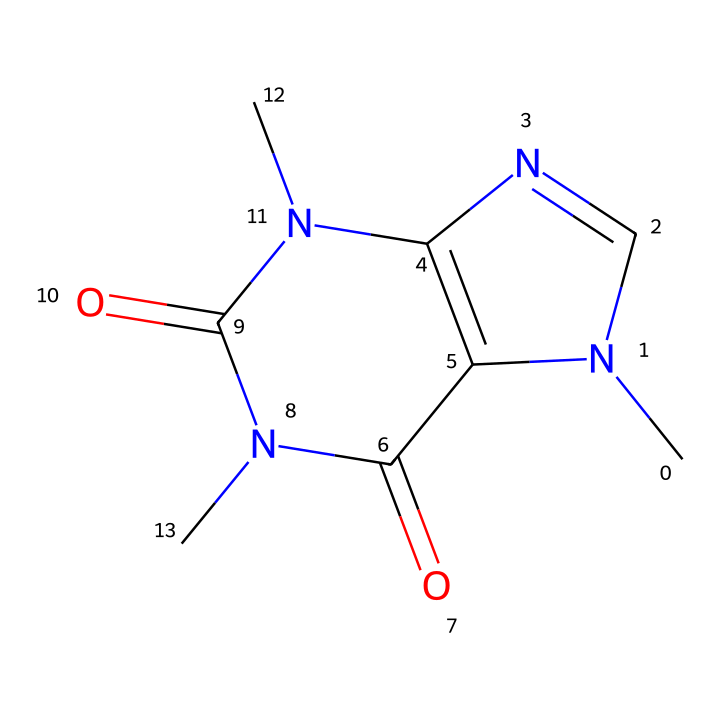What is the molecular formula for this compound? By analyzing the structure, we can count each type of atom present. The chemical contains 8 carbon (C) atoms, 10 hydrogen (H) atoms, and 4 nitrogen (N) atoms, leading to the molecular formula C8H10N4O2.
Answer: C8H10N4O2 How many rings are in this chemical structure? The structure shows that there are two interconnected ring systems. By tracing the bonds, it's clear that there are two circular arrangements present.
Answer: 2 What functional groups can be identified in this compound? Observing the structure reveals two carbonyl groups (C=O) and amine groups (N), which are indicative of its alkaloid nature. The presence of these groups highlights the overall functionality of the molecule.
Answer: amine and carbonyl Does this compound possess basic or acidic properties? Given that the chemical contains nitrogen atoms, which can accept protons, this compound is likely basic, characteristic of many alkaloids. The amine groups contribute to its basic nature.
Answer: basic What is the common characteristic of alkaloids represented in this structure? Alkaloids are often characterized by a nitrogen heteroatom in their structure. The nitrogen here plays a crucial role in forming the overall properties typical of alkaloids, such as their pharmacological effects.
Answer: nitrogen presence 